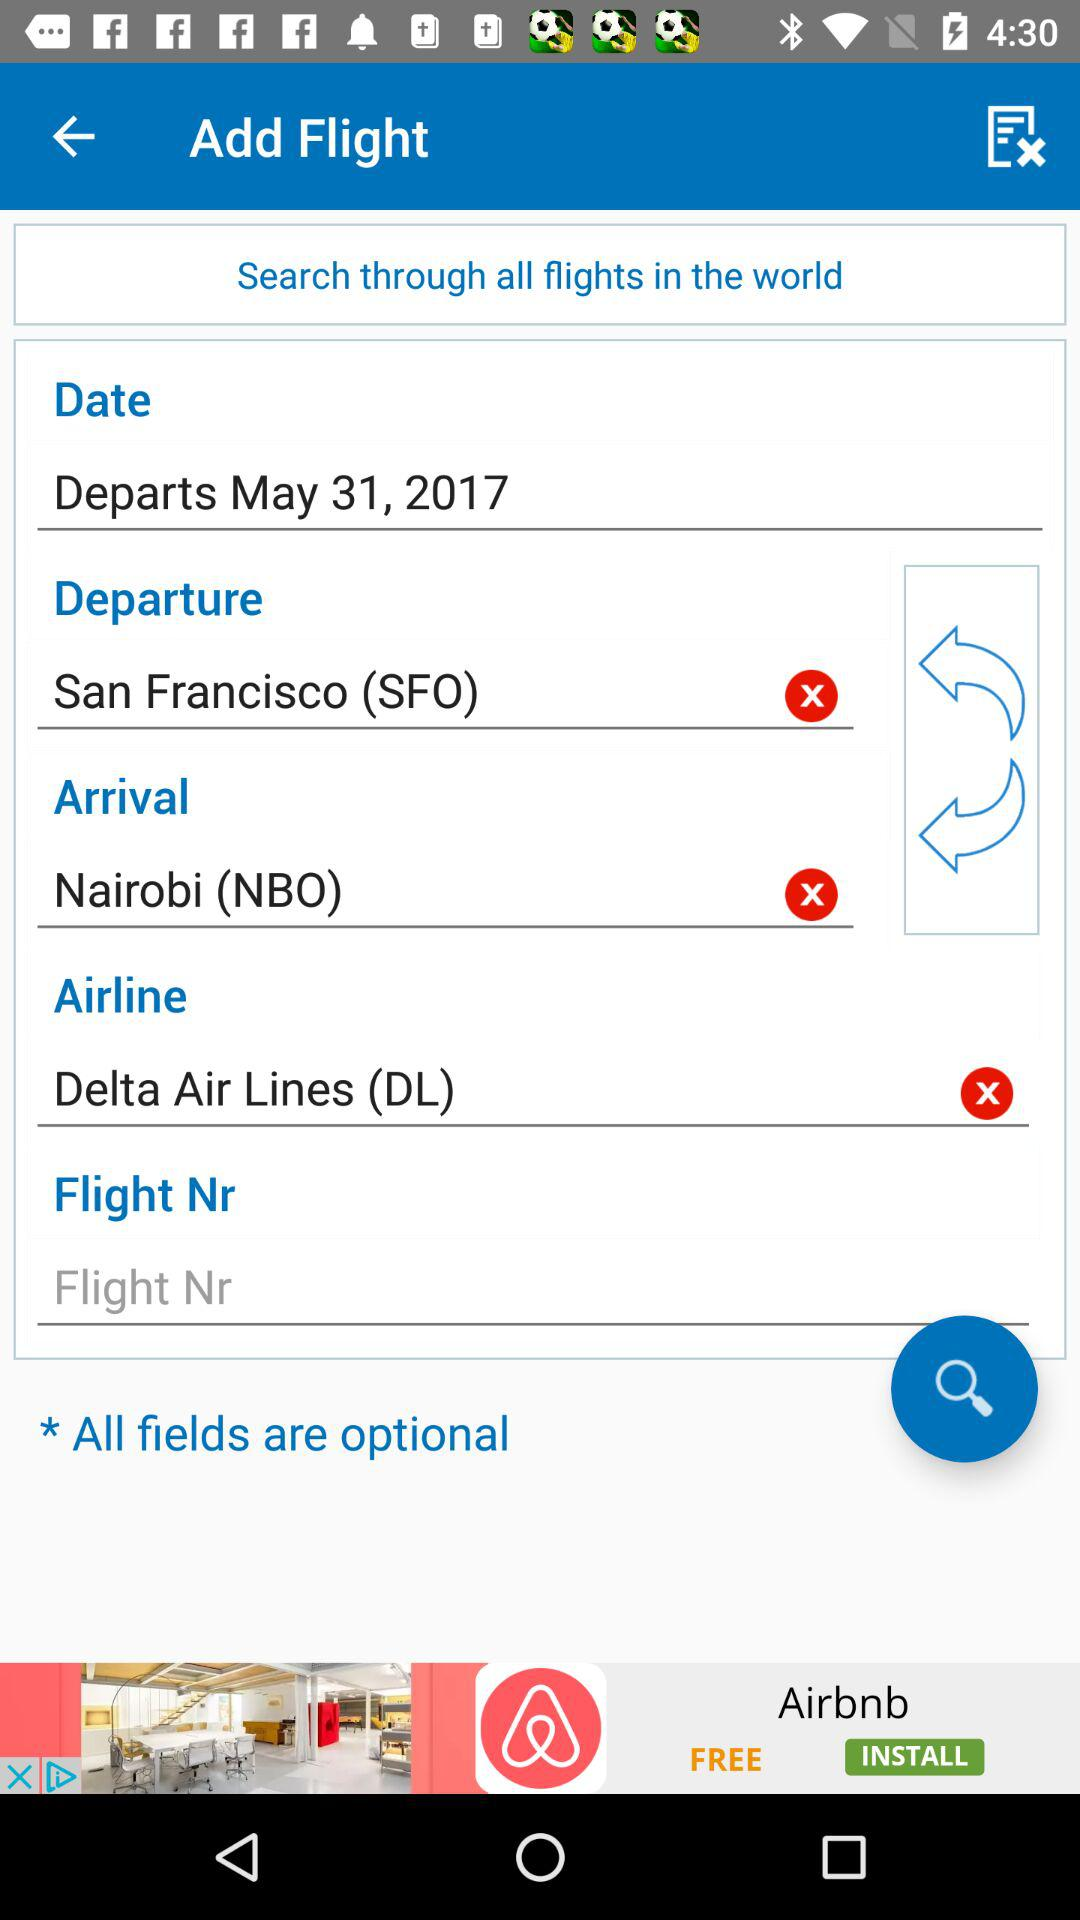What is the departure date? The departure date is May 31, 2017. 